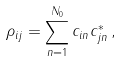<formula> <loc_0><loc_0><loc_500><loc_500>\rho _ { i j } = \sum _ { n = 1 } ^ { N _ { 0 } } c _ { i n } c _ { j n } ^ { \ast } \, ,</formula> 